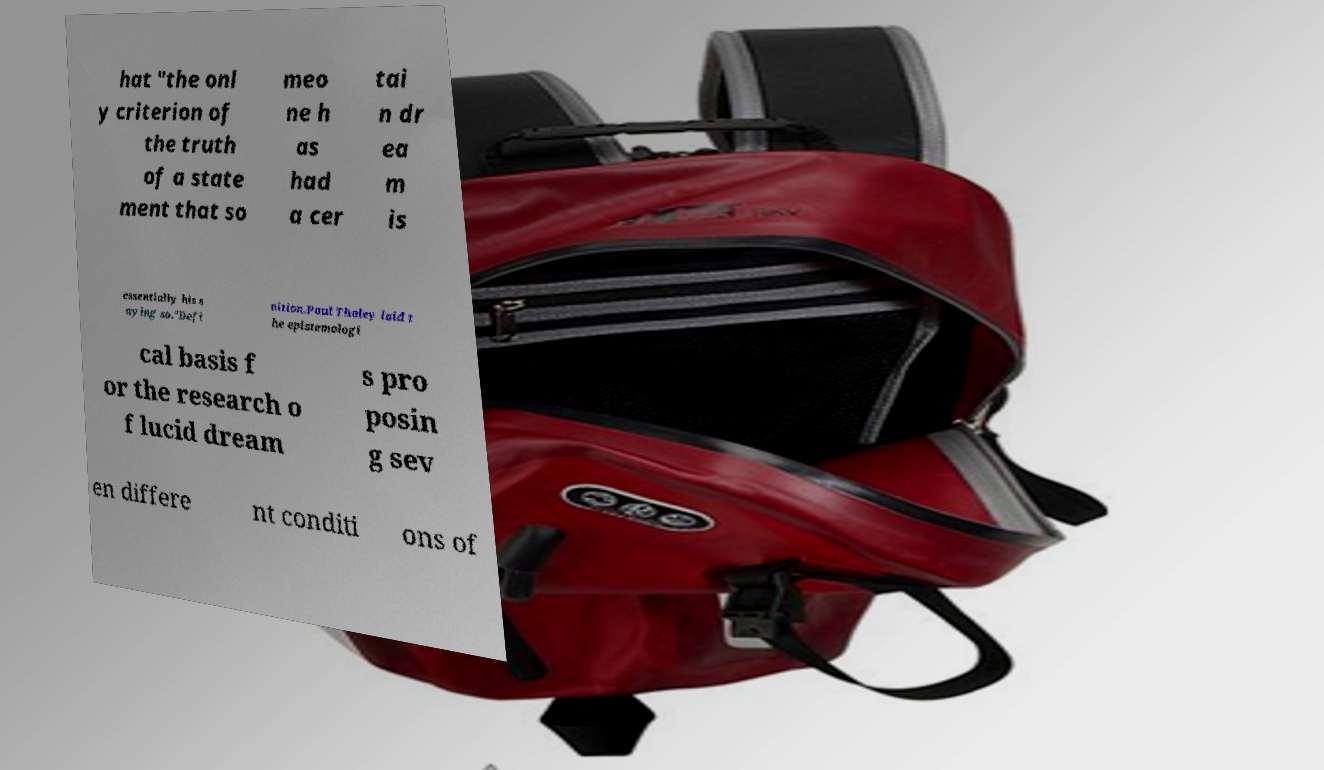Can you read and provide the text displayed in the image?This photo seems to have some interesting text. Can you extract and type it out for me? hat "the onl y criterion of the truth of a state ment that so meo ne h as had a cer tai n dr ea m is essentially his s aying so."Defi nition.Paul Tholey laid t he epistemologi cal basis f or the research o f lucid dream s pro posin g sev en differe nt conditi ons of 